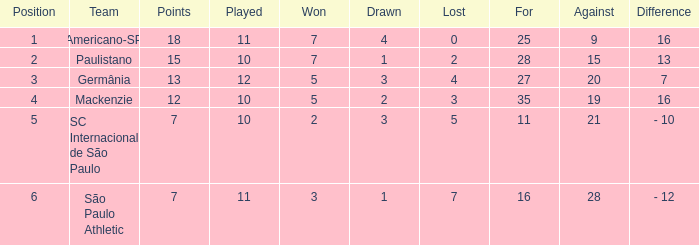Determine the smallest when the performed action results in 12. 27.0. 